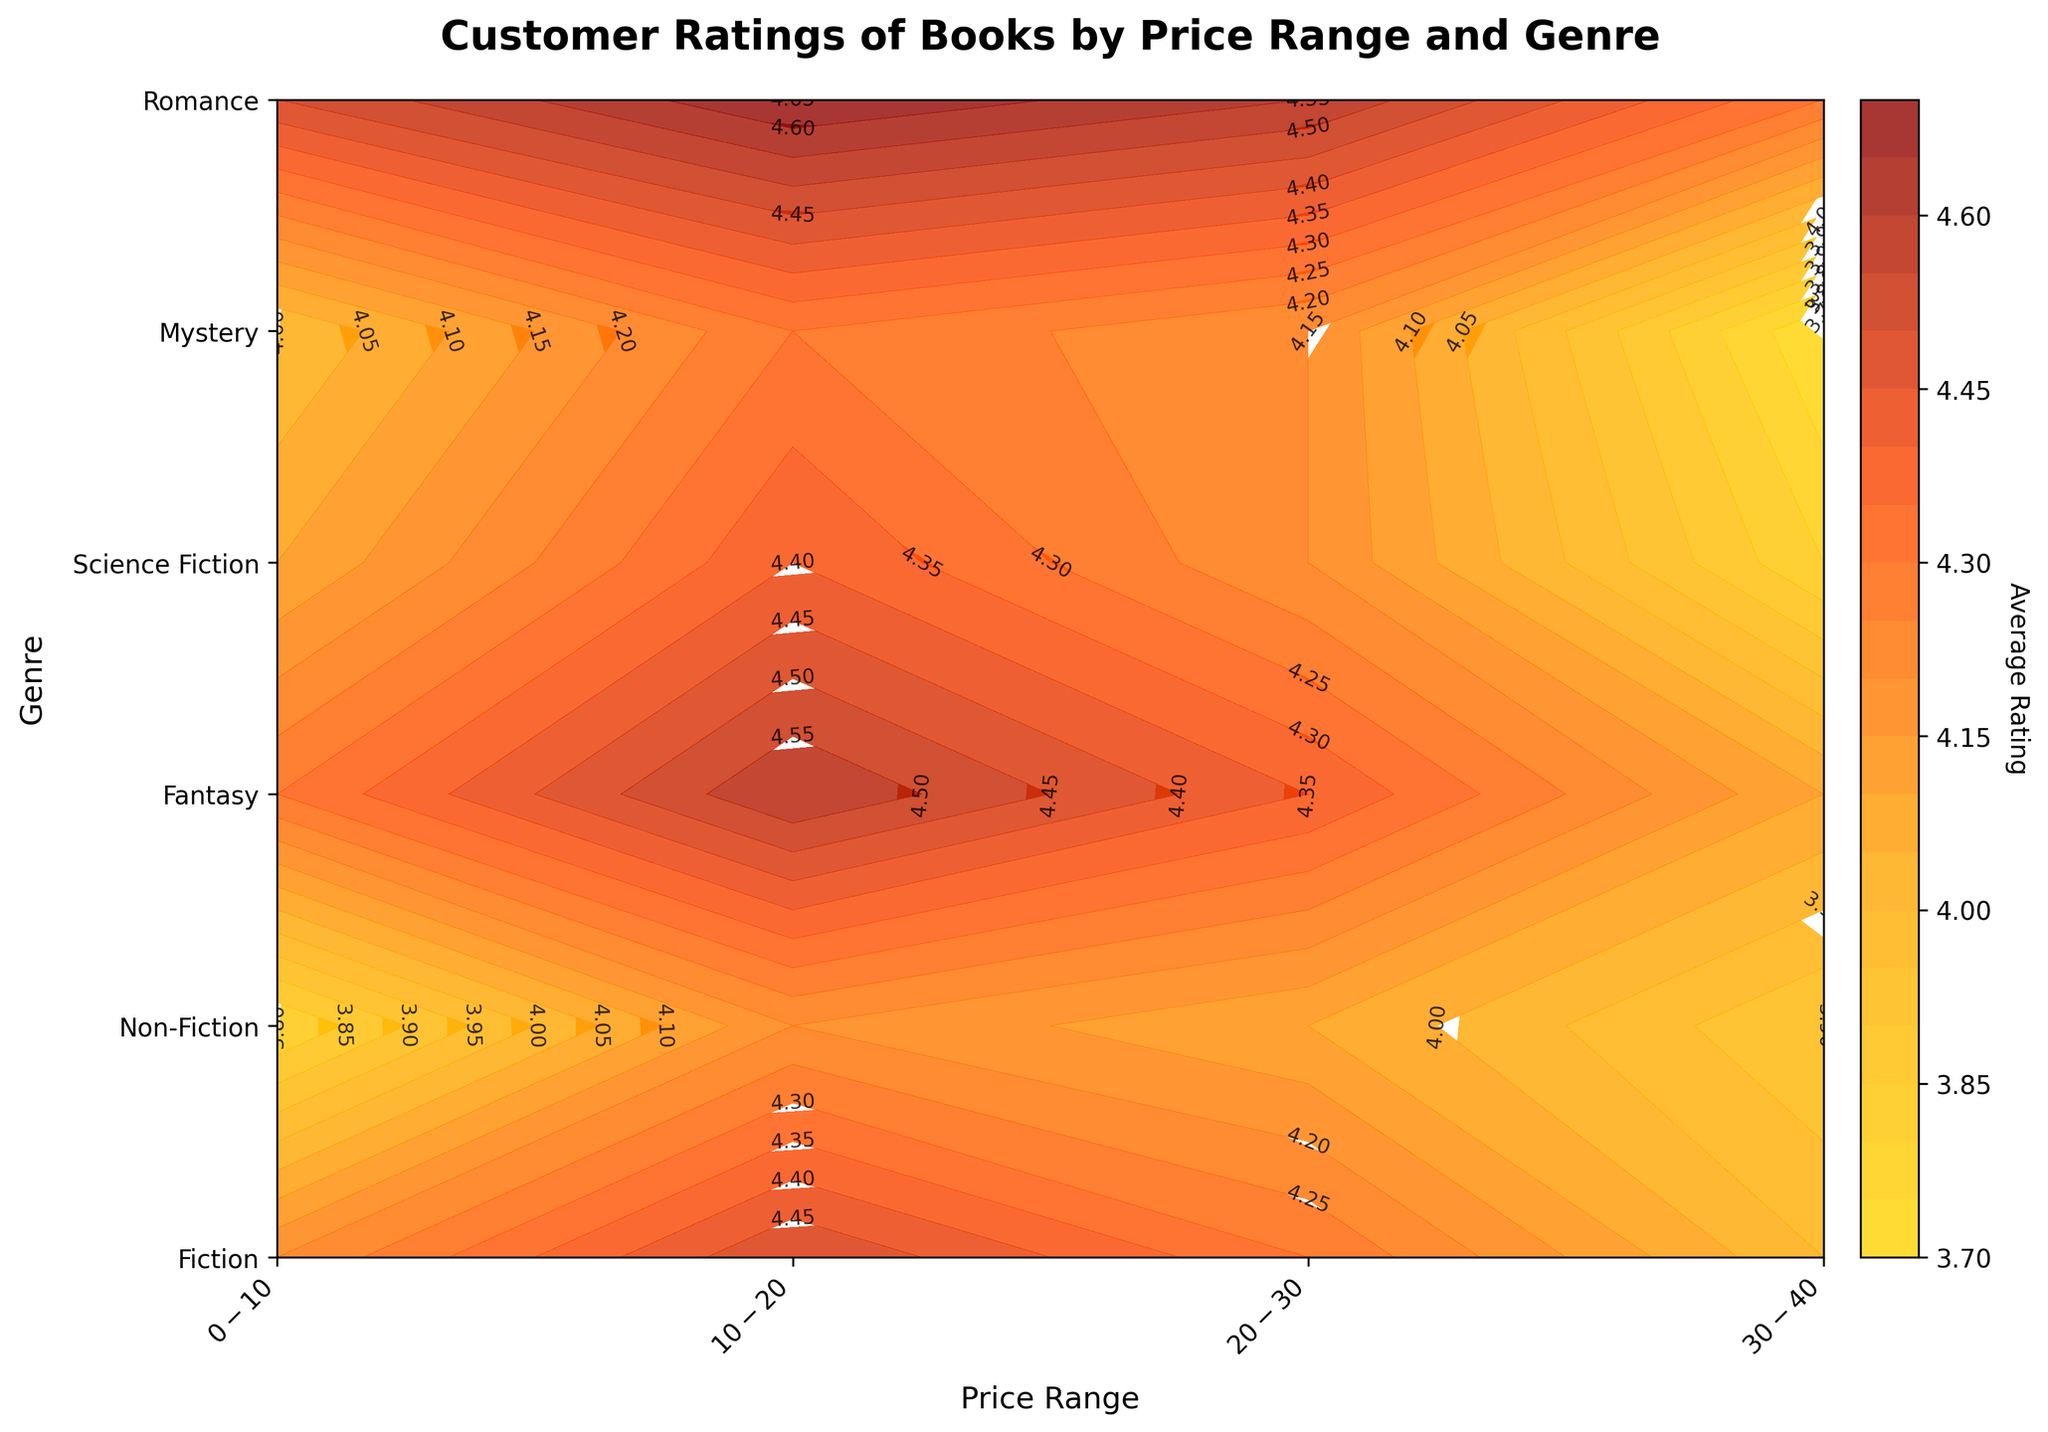What is the title of the figure? The title of the figure is written at the top center of the plot and it reads "Customer Ratings of Books by Price Range and Genre".
Answer: Customer Ratings of Books by Price Range and Genre How many price ranges are there? The x-axis of the plot shows the price ranges as $0-$10, $10-$20, $20-$30, and $30-$40. Counting these labels gives four price ranges.
Answer: Four Which genre has the highest average rating in the $10-$20 price range? By looking at the contour plot, the $10-$20 price range intersects with each genre, and we observe the contour labels. "Romance" genre in this price range has the highest rating of 4.7.
Answer: Romance What is the average rating for Non-Fiction books in the $20-$30 price range? By checking the contour plot at the position where "Non-Fiction" genre intersects with the $20-$30 price range and referring to the contour labels, the average rating is 4.1.
Answer: 4.1 Which genre has the lowest rating for books in the $30-$40 price range? To find this, we observe the contour plot at the $30-$40 price range for all genres and look for the lowest value. "Mystery" genre has the lowest rating of 3.7 in this price range.
Answer: Mystery Comparing the $0-$10 price range, which genre shows a higher average rating: Fiction or Mystery? By examining the contour labels in the $0-$10 price range for both Fiction (4.2) and Mystery (4.0) genres, Fiction has a higher average rating.
Answer: Fiction What is the difference in average rating between Fantasy and Science Fiction in the $10-$20 price range? Locate the contour labels for both Fantasy (4.6) and Science Fiction (4.4) in the $10-$20 price range. Subtract the values: 4.6 - 4.4 = 0.2.
Answer: 0.2 If considering only the $20-$30 price range, which genre has the highest rating? By looking at the $20-$30 price range and observing the contour labels for all genres, "Romance" has the highest rating of 4.6.
Answer: Romance What is the average of the highest ratings across all genres? The highest ratings for each genre as seen from the contour plot are: Fiction (4.5), Non-Fiction (4.2), Fantasy (4.6), Science Fiction (4.4), Mystery (4.3), Romance (4.7). Summing them gives 26.7, and the average is 26.7 / 6 = 4.45.
Answer: 4.45 